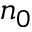Convert formula to latex. <formula><loc_0><loc_0><loc_500><loc_500>n _ { 0 }</formula> 